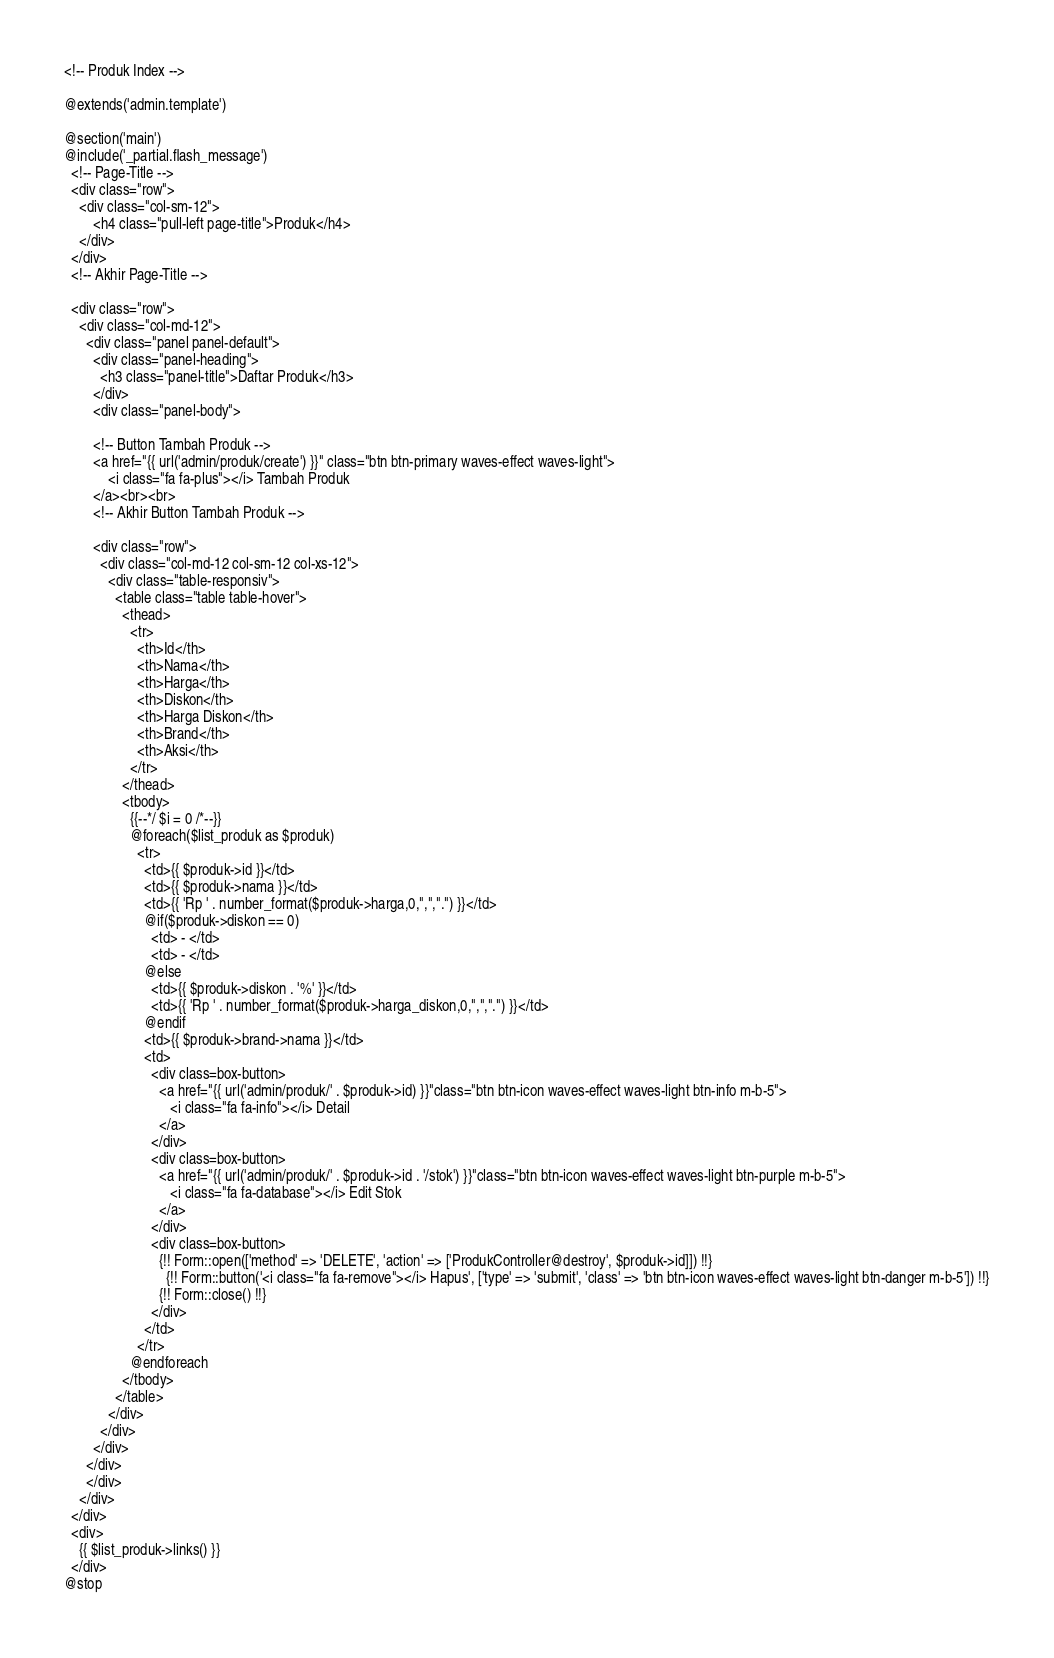Convert code to text. <code><loc_0><loc_0><loc_500><loc_500><_PHP_><!-- Produk Index -->

@extends('admin.template')

@section('main')
@include('_partial.flash_message')
  <!-- Page-Title -->
  <div class="row">
    <div class="col-sm-12">
        <h4 class="pull-left page-title">Produk</h4>
    </div>
  </div>
  <!-- Akhir Page-Title -->

  <div class="row">
    <div class="col-md-12">
      <div class="panel panel-default">
        <div class="panel-heading">
          <h3 class="panel-title">Daftar Produk</h3>
        </div>
        <div class="panel-body">

        <!-- Button Tambah Produk -->
        <a href="{{ url('admin/produk/create') }}" class="btn btn-primary waves-effect waves-light">
            <i class="fa fa-plus"></i> Tambah Produk
        </a><br><br>
        <!-- Akhir Button Tambah Produk -->

        <div class="row">
          <div class="col-md-12 col-sm-12 col-xs-12">
            <div class="table-responsiv">
              <table class="table table-hover">
                <thead>
                  <tr>
                    <th>Id</th>
                    <th>Nama</th>
                    <th>Harga</th>
                    <th>Diskon</th>
                    <th>Harga Diskon</th>
                    <th>Brand</th>
                    <th>Aksi</th>
                  </tr>
                </thead>
                <tbody>
                  {{--*/ $i = 0 /*--}}
                  @foreach($list_produk as $produk)
                    <tr>
                      <td>{{ $produk->id }}</td>
                      <td>{{ $produk->nama }}</td>
                      <td>{{ 'Rp ' . number_format($produk->harga,0,",",".") }}</td>
                      @if($produk->diskon == 0)
                        <td> - </td>
                        <td> - </td>
                      @else
                        <td>{{ $produk->diskon . '%' }}</td>
                        <td>{{ 'Rp ' . number_format($produk->harga_diskon,0,",",".") }}</td>
                      @endif
                      <td>{{ $produk->brand->nama }}</td>
                      <td>
                        <div class=box-button>
                          <a href="{{ url('admin/produk/' . $produk->id) }}"class="btn btn-icon waves-effect waves-light btn-info m-b-5">
                             <i class="fa fa-info"></i> Detail
                          </a>
                        </div>
                        <div class=box-button>
                          <a href="{{ url('admin/produk/' . $produk->id . '/stok') }}"class="btn btn-icon waves-effect waves-light btn-purple m-b-5">
                             <i class="fa fa-database"></i> Edit Stok
                          </a>
                        </div>
                        <div class=box-button>
                          {!! Form::open(['method' => 'DELETE', 'action' => ['ProdukController@destroy', $produk->id]]) !!}
                            {!! Form::button('<i class="fa fa-remove"></i> Hapus', ['type' => 'submit', 'class' => 'btn btn-icon waves-effect waves-light btn-danger m-b-5']) !!}
                          {!! Form::close() !!}
                        </div>
                      </td>
                    </tr>
                  @endforeach
                </tbody>
              </table>
            </div>
          </div>
        </div>
      </div>
      </div>
    </div>
  </div>
  <div>
    {{ $list_produk->links() }}
  </div>
@stop
</code> 